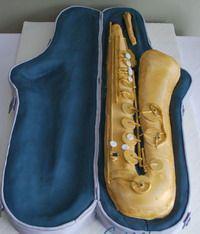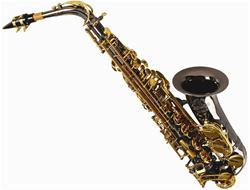The first image is the image on the left, the second image is the image on the right. Assess this claim about the two images: "The right image shows a dark saxophone with gold buttons displayed diagonally, with its mouthpiece at the upper left and its bell upturned.". Correct or not? Answer yes or no. Yes. The first image is the image on the left, the second image is the image on the right. Examine the images to the left and right. Is the description "One of the sax's is inside its case." accurate? Answer yes or no. Yes. 